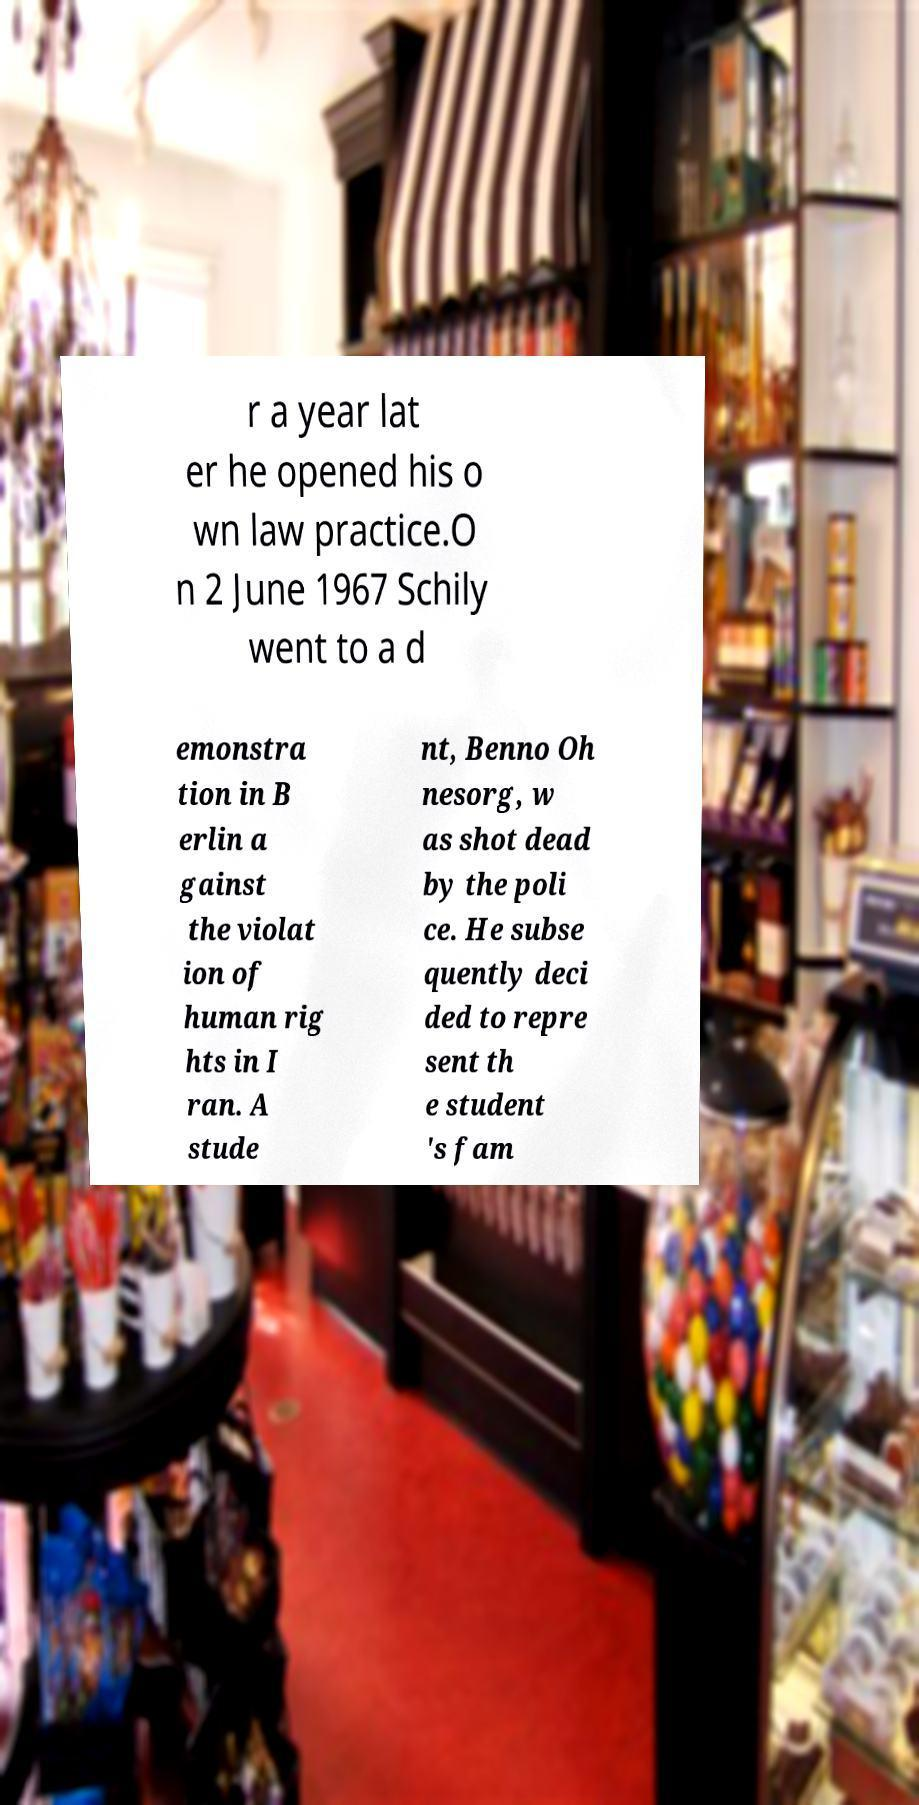Please identify and transcribe the text found in this image. r a year lat er he opened his o wn law practice.O n 2 June 1967 Schily went to a d emonstra tion in B erlin a gainst the violat ion of human rig hts in I ran. A stude nt, Benno Oh nesorg, w as shot dead by the poli ce. He subse quently deci ded to repre sent th e student 's fam 